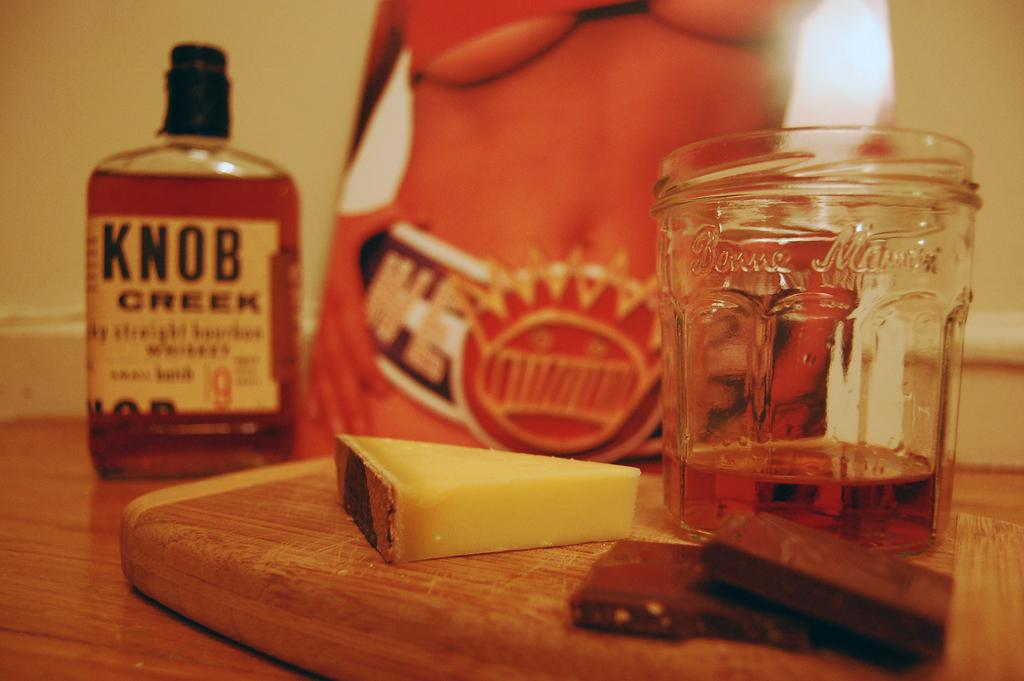<image>
Write a terse but informative summary of the picture. A close up view of a cheeseboard with a slice of cheese, some chocolate, a glass with partially filled whiskey, and a full bottle of Knob Creek whiskey. 